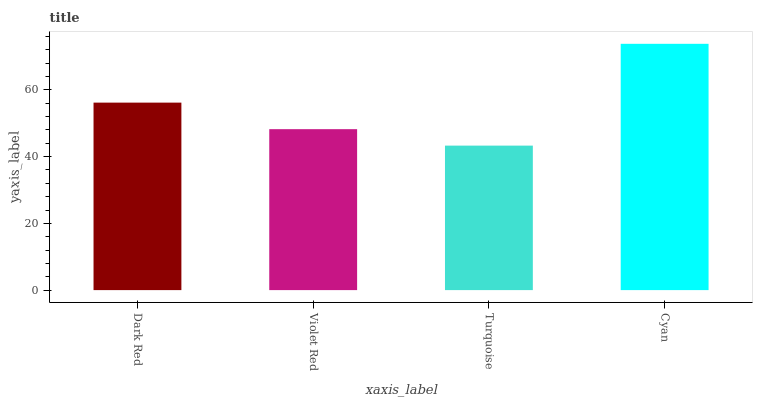Is Turquoise the minimum?
Answer yes or no. Yes. Is Cyan the maximum?
Answer yes or no. Yes. Is Violet Red the minimum?
Answer yes or no. No. Is Violet Red the maximum?
Answer yes or no. No. Is Dark Red greater than Violet Red?
Answer yes or no. Yes. Is Violet Red less than Dark Red?
Answer yes or no. Yes. Is Violet Red greater than Dark Red?
Answer yes or no. No. Is Dark Red less than Violet Red?
Answer yes or no. No. Is Dark Red the high median?
Answer yes or no. Yes. Is Violet Red the low median?
Answer yes or no. Yes. Is Violet Red the high median?
Answer yes or no. No. Is Turquoise the low median?
Answer yes or no. No. 